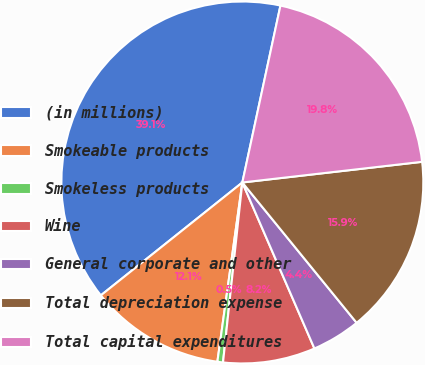Convert chart to OTSL. <chart><loc_0><loc_0><loc_500><loc_500><pie_chart><fcel>(in millions)<fcel>Smokeable products<fcel>Smokeless products<fcel>Wine<fcel>General corporate and other<fcel>Total depreciation expense<fcel>Total capital expenditures<nl><fcel>39.09%<fcel>12.08%<fcel>0.5%<fcel>8.22%<fcel>4.36%<fcel>15.94%<fcel>19.8%<nl></chart> 